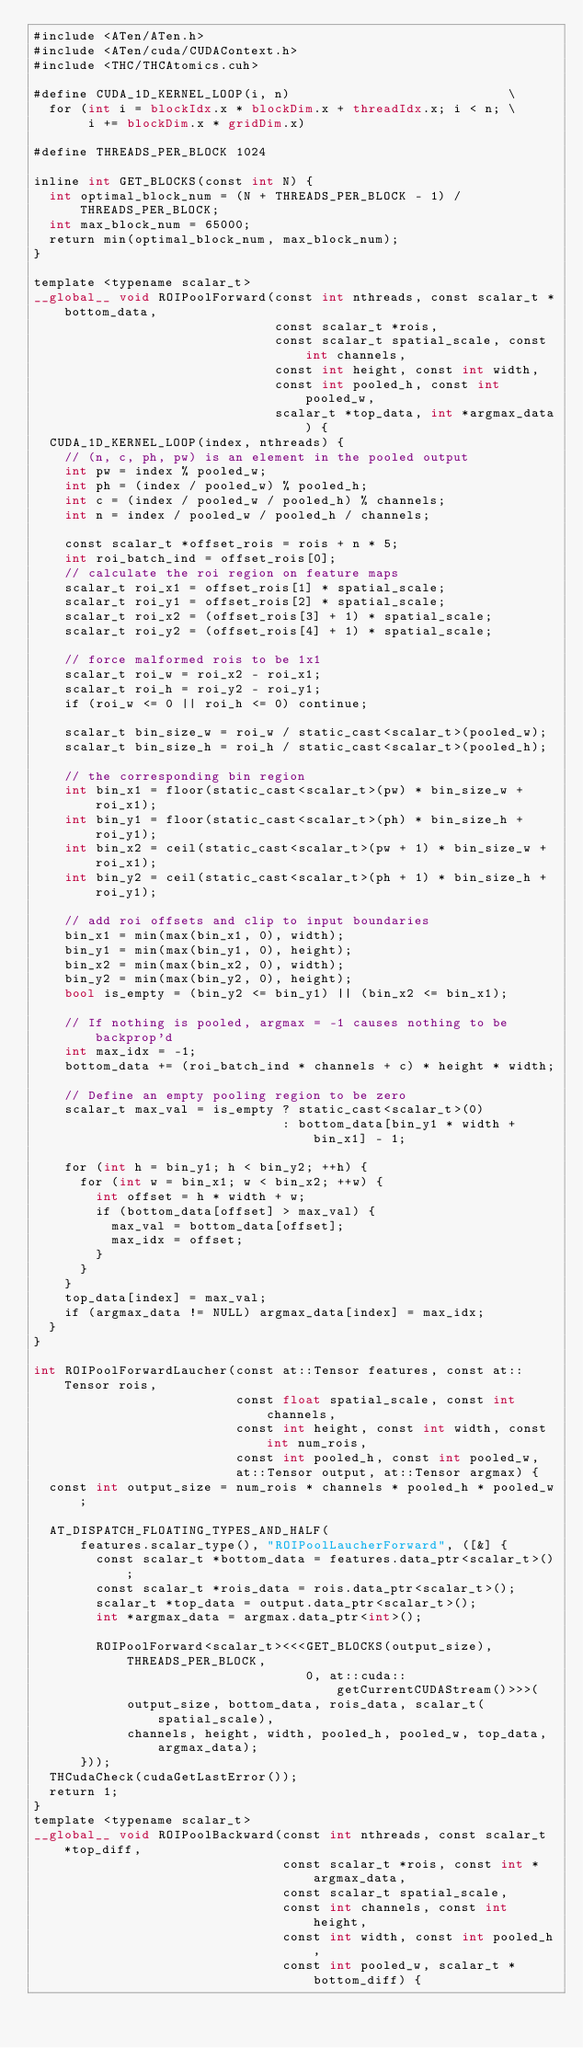Convert code to text. <code><loc_0><loc_0><loc_500><loc_500><_Cuda_>#include <ATen/ATen.h>
#include <ATen/cuda/CUDAContext.h>
#include <THC/THCAtomics.cuh>

#define CUDA_1D_KERNEL_LOOP(i, n)                            \
  for (int i = blockIdx.x * blockDim.x + threadIdx.x; i < n; \
       i += blockDim.x * gridDim.x)

#define THREADS_PER_BLOCK 1024

inline int GET_BLOCKS(const int N) {
  int optimal_block_num = (N + THREADS_PER_BLOCK - 1) / THREADS_PER_BLOCK;
  int max_block_num = 65000;
  return min(optimal_block_num, max_block_num);
}

template <typename scalar_t>
__global__ void ROIPoolForward(const int nthreads, const scalar_t *bottom_data,
                               const scalar_t *rois,
                               const scalar_t spatial_scale, const int channels,
                               const int height, const int width,
                               const int pooled_h, const int pooled_w,
                               scalar_t *top_data, int *argmax_data) {
  CUDA_1D_KERNEL_LOOP(index, nthreads) {
    // (n, c, ph, pw) is an element in the pooled output
    int pw = index % pooled_w;
    int ph = (index / pooled_w) % pooled_h;
    int c = (index / pooled_w / pooled_h) % channels;
    int n = index / pooled_w / pooled_h / channels;

    const scalar_t *offset_rois = rois + n * 5;
    int roi_batch_ind = offset_rois[0];
    // calculate the roi region on feature maps
    scalar_t roi_x1 = offset_rois[1] * spatial_scale;
    scalar_t roi_y1 = offset_rois[2] * spatial_scale;
    scalar_t roi_x2 = (offset_rois[3] + 1) * spatial_scale;
    scalar_t roi_y2 = (offset_rois[4] + 1) * spatial_scale;

    // force malformed rois to be 1x1
    scalar_t roi_w = roi_x2 - roi_x1;
    scalar_t roi_h = roi_y2 - roi_y1;
    if (roi_w <= 0 || roi_h <= 0) continue;

    scalar_t bin_size_w = roi_w / static_cast<scalar_t>(pooled_w);
    scalar_t bin_size_h = roi_h / static_cast<scalar_t>(pooled_h);

    // the corresponding bin region
    int bin_x1 = floor(static_cast<scalar_t>(pw) * bin_size_w + roi_x1);
    int bin_y1 = floor(static_cast<scalar_t>(ph) * bin_size_h + roi_y1);
    int bin_x2 = ceil(static_cast<scalar_t>(pw + 1) * bin_size_w + roi_x1);
    int bin_y2 = ceil(static_cast<scalar_t>(ph + 1) * bin_size_h + roi_y1);

    // add roi offsets and clip to input boundaries
    bin_x1 = min(max(bin_x1, 0), width);
    bin_y1 = min(max(bin_y1, 0), height);
    bin_x2 = min(max(bin_x2, 0), width);
    bin_y2 = min(max(bin_y2, 0), height);
    bool is_empty = (bin_y2 <= bin_y1) || (bin_x2 <= bin_x1);

    // If nothing is pooled, argmax = -1 causes nothing to be backprop'd
    int max_idx = -1;
    bottom_data += (roi_batch_ind * channels + c) * height * width;

    // Define an empty pooling region to be zero
    scalar_t max_val = is_empty ? static_cast<scalar_t>(0)
                                : bottom_data[bin_y1 * width + bin_x1] - 1;

    for (int h = bin_y1; h < bin_y2; ++h) {
      for (int w = bin_x1; w < bin_x2; ++w) {
        int offset = h * width + w;
        if (bottom_data[offset] > max_val) {
          max_val = bottom_data[offset];
          max_idx = offset;
        }
      }
    }
    top_data[index] = max_val;
    if (argmax_data != NULL) argmax_data[index] = max_idx;
  }
}

int ROIPoolForwardLaucher(const at::Tensor features, const at::Tensor rois,
                          const float spatial_scale, const int channels,
                          const int height, const int width, const int num_rois,
                          const int pooled_h, const int pooled_w,
                          at::Tensor output, at::Tensor argmax) {
  const int output_size = num_rois * channels * pooled_h * pooled_w;

  AT_DISPATCH_FLOATING_TYPES_AND_HALF(
      features.scalar_type(), "ROIPoolLaucherForward", ([&] {
        const scalar_t *bottom_data = features.data_ptr<scalar_t>();
        const scalar_t *rois_data = rois.data_ptr<scalar_t>();
        scalar_t *top_data = output.data_ptr<scalar_t>();
        int *argmax_data = argmax.data_ptr<int>();

        ROIPoolForward<scalar_t><<<GET_BLOCKS(output_size), THREADS_PER_BLOCK,
                                   0, at::cuda::getCurrentCUDAStream()>>>(
            output_size, bottom_data, rois_data, scalar_t(spatial_scale),
            channels, height, width, pooled_h, pooled_w, top_data, argmax_data);
      }));
  THCudaCheck(cudaGetLastError());
  return 1;
}
template <typename scalar_t>
__global__ void ROIPoolBackward(const int nthreads, const scalar_t *top_diff,
                                const scalar_t *rois, const int *argmax_data,
                                const scalar_t spatial_scale,
                                const int channels, const int height,
                                const int width, const int pooled_h,
                                const int pooled_w, scalar_t *bottom_diff) {</code> 